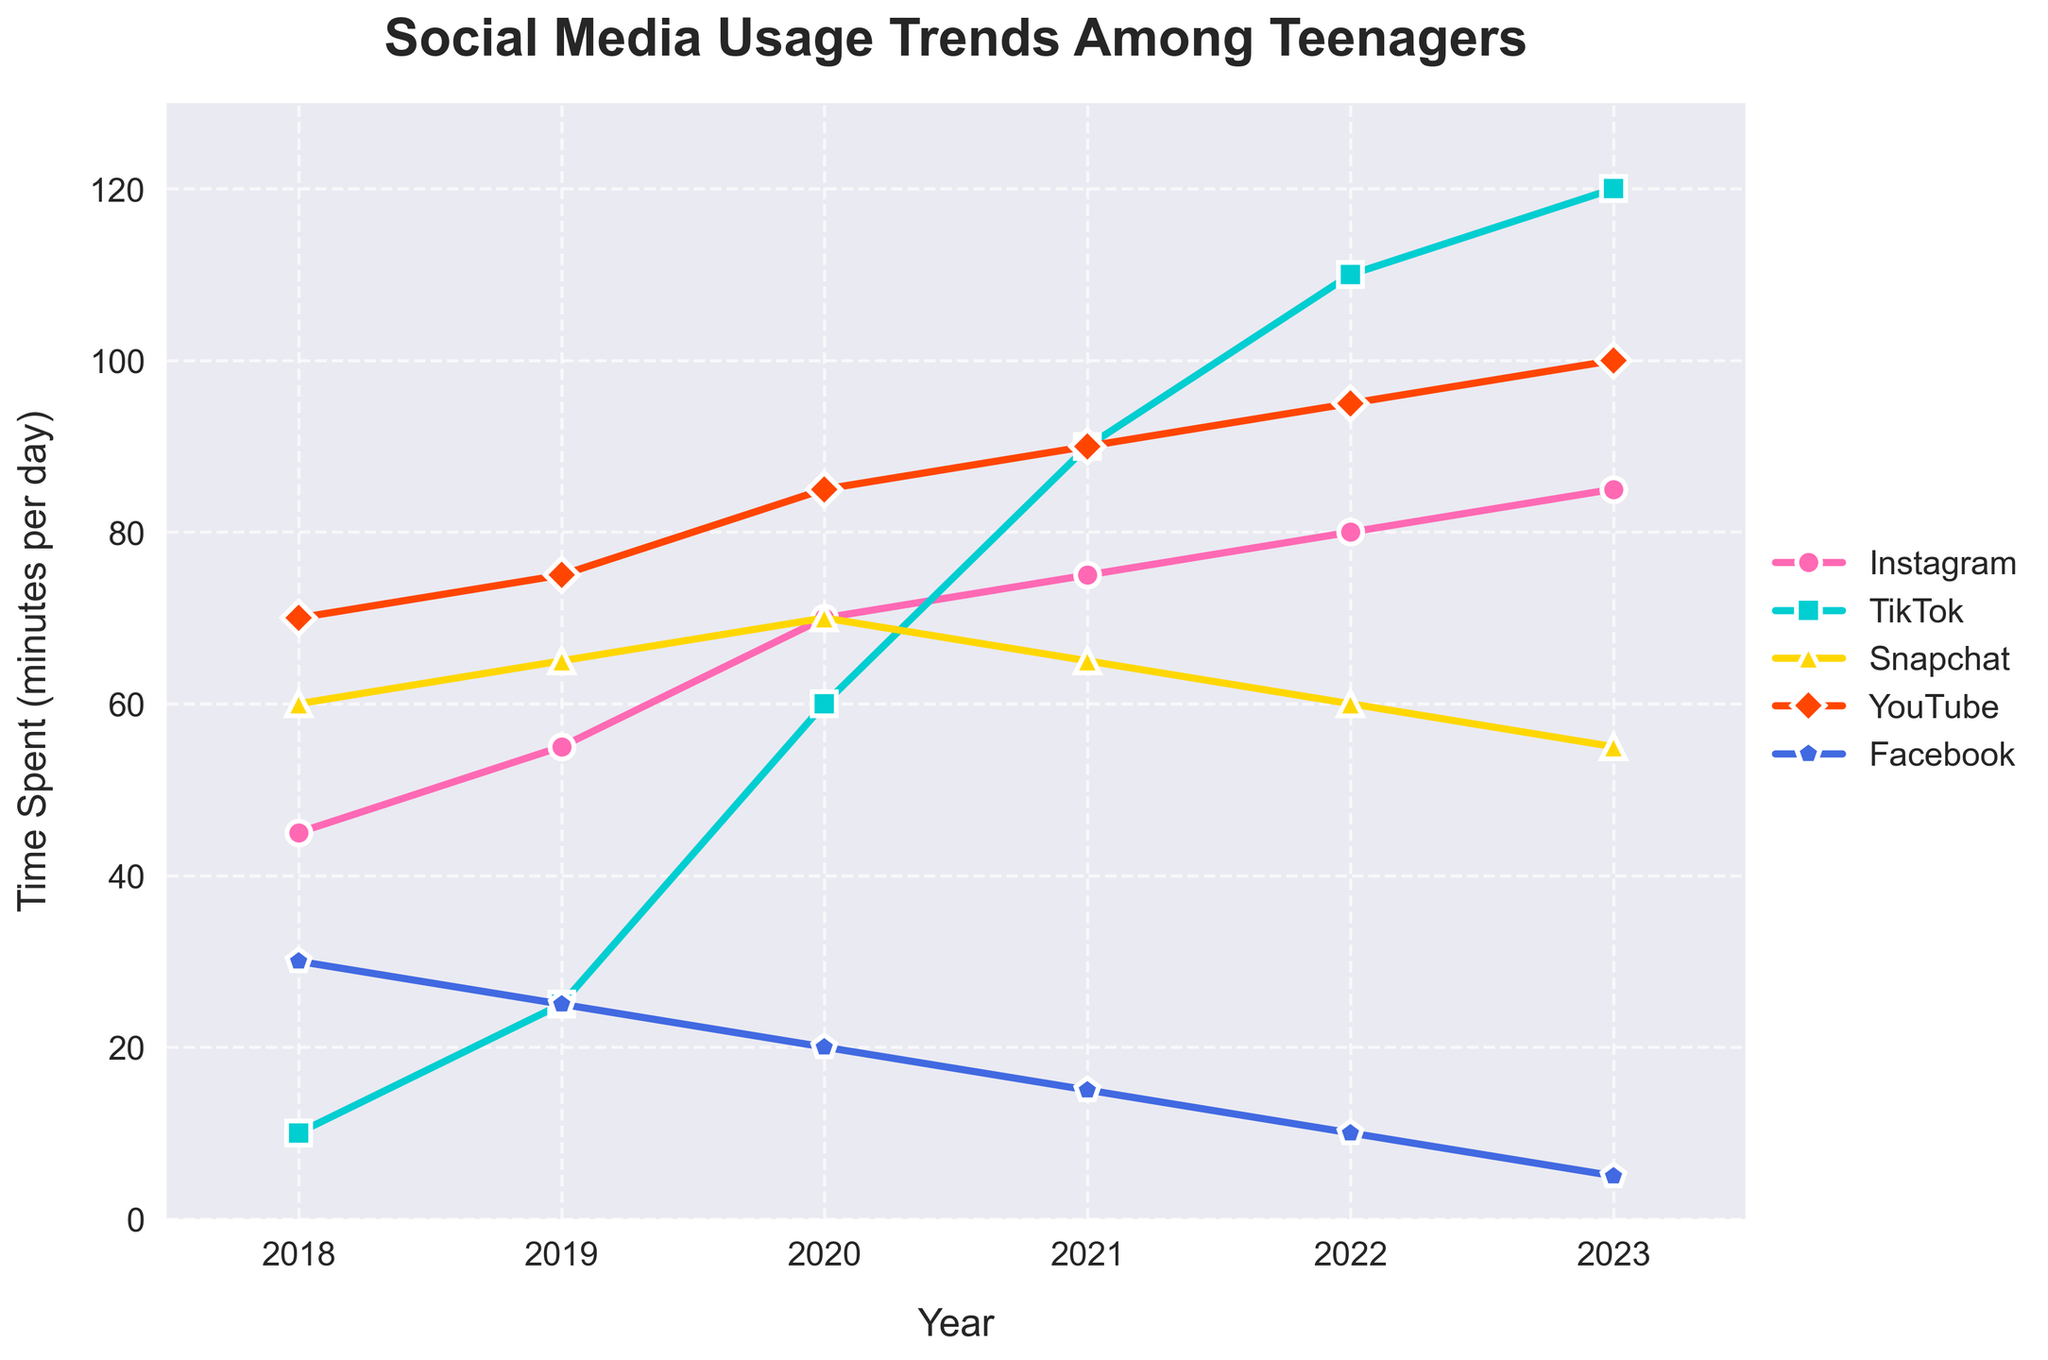How did the usage of TikTok change from 2018 to 2023? Looking at the plot, TikTok usage in 2018 was at 10 minutes per day. By 2023, it increased significantly to 120 minutes per day. The trend indicates a consistent rise in TikTok usage over the years.
Answer: It increased by 110 minutes Which two social media platforms have seen a decline in usage from 2021 to 2023? By observing the lines on the plot between 2021 and 2023, Snapchat and Facebook show a decline. Snapchat drops from 65 to 55 minutes per day, and Facebook drops from 15 to 5 minutes per day.
Answer: Snapchat and Facebook Which platform had the most time spent on it in 2023, and how much time was that? The highest line in 2023 represents YouTube, which teenagers spent 100 minutes per day on, making it the platform with the most usage.
Answer: YouTube, 100 minutes From 2018 to 2023, which platform showed the most consistent increase in usage each year? TikTok had a steady and significant rise each year. Starting at 10 minutes in 2018, it increased yearly to 120 minutes by 2023. This displays a clear and consistent growth trend.
Answer: TikTok In 2022, which platform was used the least and what was the usage time? The lowest line in 2022 corresponds to Facebook, with teenagers spending only 10 minutes per day on the platform.
Answer: Facebook, 10 minutes What was the total time spent on Instagram and Snapchat combined in 2020? From the plot, Instagram usage in 2020 was 70 minutes per day, and Snapchat was also 70 minutes per day. Adding these gives a total of 140 minutes per day.
Answer: 140 minutes Which platform experienced the highest increase in usage from 2019 to 2020? TikTok's usage rose from 25 minutes to 60 minutes from 2019 to 2020, an increase of 35 minutes, the highest compared to other platforms in the same period.
Answer: TikTok Compare the trend of Facebook usage with Instagram usage from 2018 to 2023. Facebook usage consistently declined from 30 minutes in 2018 to 5 minutes in 2023. Conversely, Instagram usage steadily increased from 45 minutes in 2018 to 85 minutes in 2023. These two trends are opposite to each other.
Answer: Facebook declined, Instagram increased What was the average time spent on Snapchat from 2018 to 2023? The plot shows times spent on Snapchat as 60, 65, 70, 65, 60, and 55 minutes per day from 2018 to 2023. Summing these gives 375 minutes, and the average over 6 years is 375/6 ≈ 62.5 minutes per day.
Answer: 62.5 minutes By how much did YouTube usage increase from the year 2020 to 2023? Observing the YouTube line, usage increased from 85 minutes in 2020 to 100 minutes in 2023. This is an increase of 15 minutes over three years.
Answer: 15 minutes 